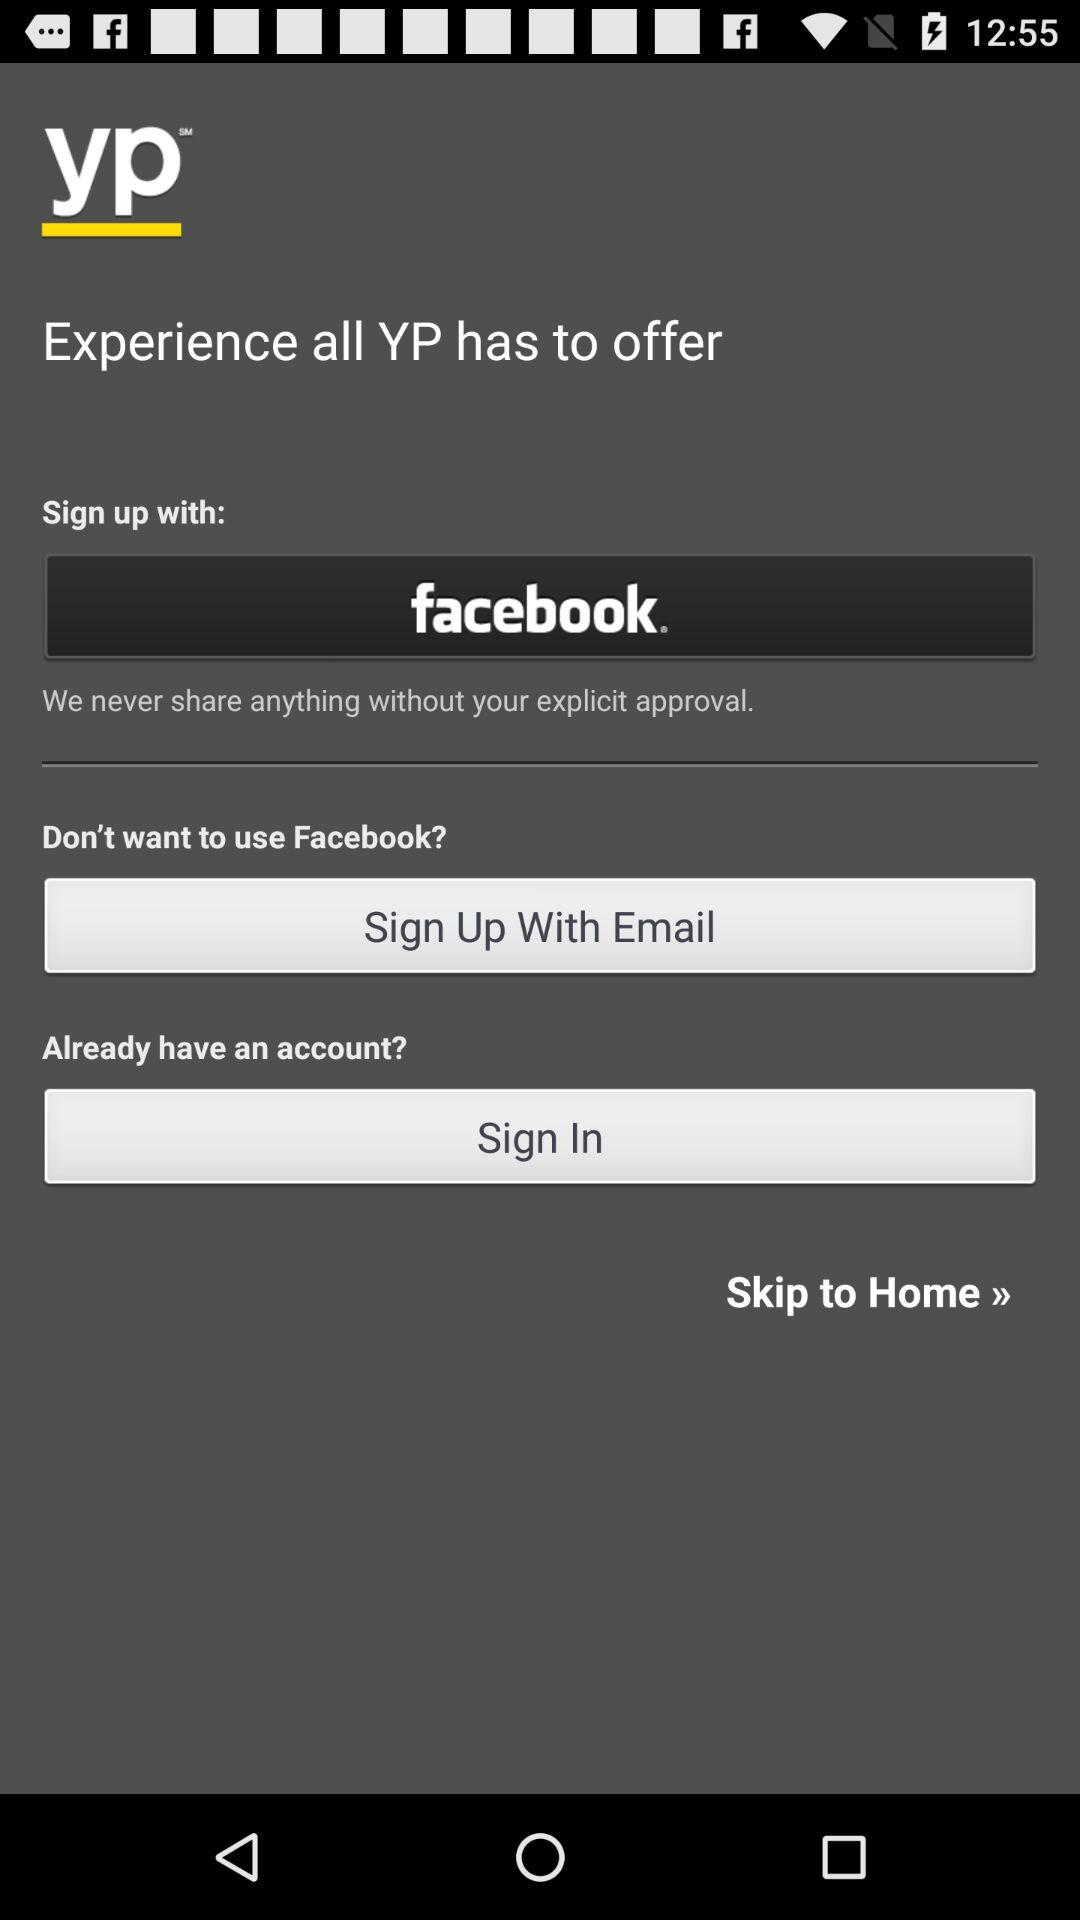What social apps can we use to sign in? The social apps that you can use to sign in is "facebook". 